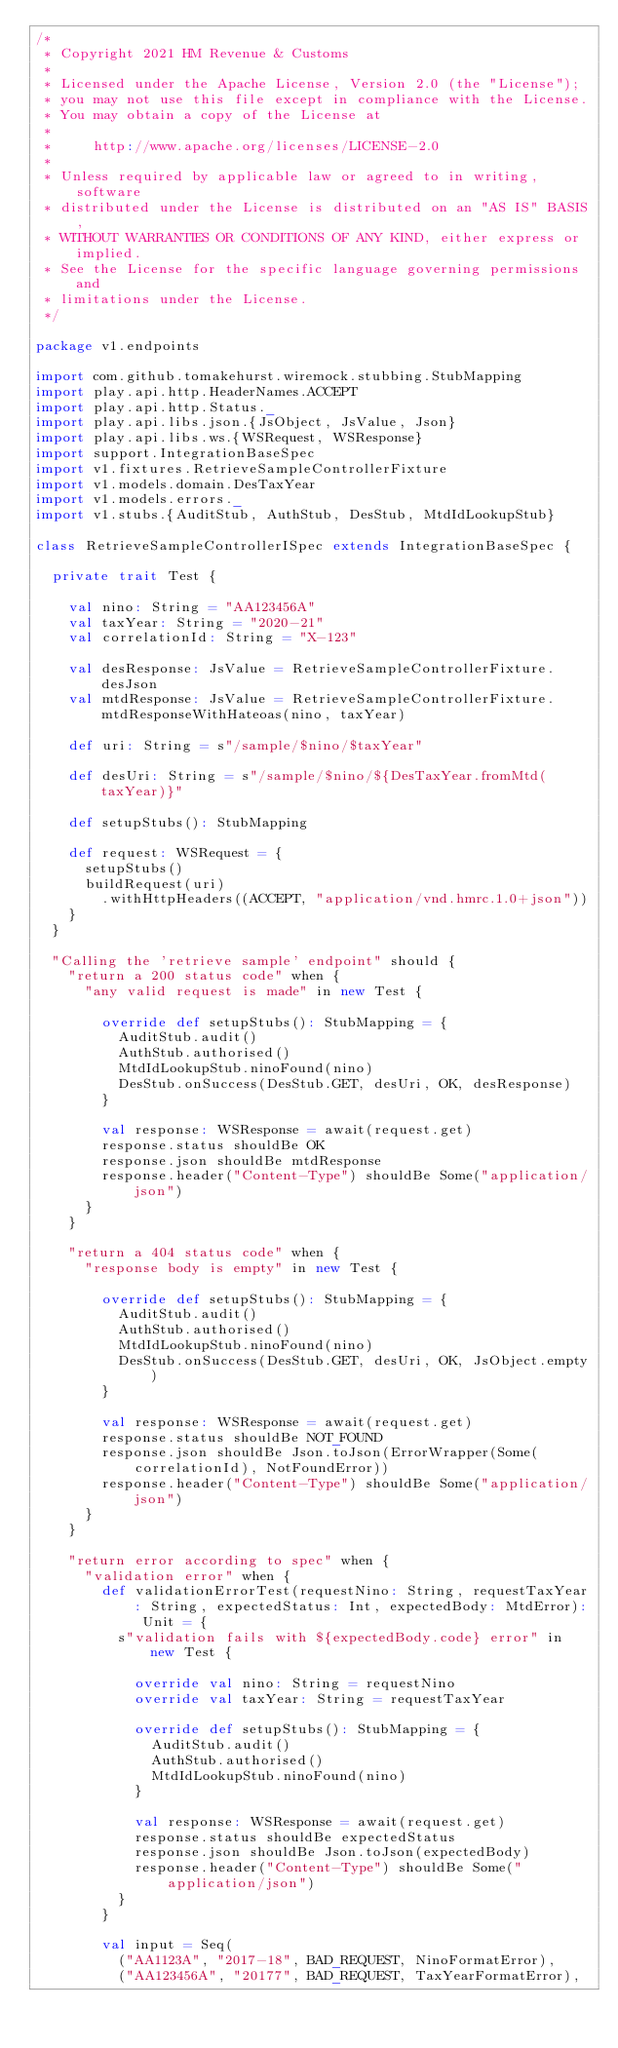<code> <loc_0><loc_0><loc_500><loc_500><_Scala_>/*
 * Copyright 2021 HM Revenue & Customs
 *
 * Licensed under the Apache License, Version 2.0 (the "License");
 * you may not use this file except in compliance with the License.
 * You may obtain a copy of the License at
 *
 *     http://www.apache.org/licenses/LICENSE-2.0
 *
 * Unless required by applicable law or agreed to in writing, software
 * distributed under the License is distributed on an "AS IS" BASIS,
 * WITHOUT WARRANTIES OR CONDITIONS OF ANY KIND, either express or implied.
 * See the License for the specific language governing permissions and
 * limitations under the License.
 */

package v1.endpoints

import com.github.tomakehurst.wiremock.stubbing.StubMapping
import play.api.http.HeaderNames.ACCEPT
import play.api.http.Status._
import play.api.libs.json.{JsObject, JsValue, Json}
import play.api.libs.ws.{WSRequest, WSResponse}
import support.IntegrationBaseSpec
import v1.fixtures.RetrieveSampleControllerFixture
import v1.models.domain.DesTaxYear
import v1.models.errors._
import v1.stubs.{AuditStub, AuthStub, DesStub, MtdIdLookupStub}

class RetrieveSampleControllerISpec extends IntegrationBaseSpec {

  private trait Test {

    val nino: String = "AA123456A"
    val taxYear: String = "2020-21"
    val correlationId: String = "X-123"

    val desResponse: JsValue = RetrieveSampleControllerFixture.desJson
    val mtdResponse: JsValue = RetrieveSampleControllerFixture.mtdResponseWithHateoas(nino, taxYear)

    def uri: String = s"/sample/$nino/$taxYear"

    def desUri: String = s"/sample/$nino/${DesTaxYear.fromMtd(taxYear)}"

    def setupStubs(): StubMapping

    def request: WSRequest = {
      setupStubs()
      buildRequest(uri)
        .withHttpHeaders((ACCEPT, "application/vnd.hmrc.1.0+json"))
    }
  }

  "Calling the 'retrieve sample' endpoint" should {
    "return a 200 status code" when {
      "any valid request is made" in new Test {

        override def setupStubs(): StubMapping = {
          AuditStub.audit()
          AuthStub.authorised()
          MtdIdLookupStub.ninoFound(nino)
          DesStub.onSuccess(DesStub.GET, desUri, OK, desResponse)
        }

        val response: WSResponse = await(request.get)
        response.status shouldBe OK
        response.json shouldBe mtdResponse
        response.header("Content-Type") shouldBe Some("application/json")
      }
    }

    "return a 404 status code" when {
      "response body is empty" in new Test {

        override def setupStubs(): StubMapping = {
          AuditStub.audit()
          AuthStub.authorised()
          MtdIdLookupStub.ninoFound(nino)
          DesStub.onSuccess(DesStub.GET, desUri, OK, JsObject.empty)
        }

        val response: WSResponse = await(request.get)
        response.status shouldBe NOT_FOUND
        response.json shouldBe Json.toJson(ErrorWrapper(Some(correlationId), NotFoundError))
        response.header("Content-Type") shouldBe Some("application/json")
      }
    }

    "return error according to spec" when {
      "validation error" when {
        def validationErrorTest(requestNino: String, requestTaxYear: String, expectedStatus: Int, expectedBody: MtdError): Unit = {
          s"validation fails with ${expectedBody.code} error" in new Test {

            override val nino: String = requestNino
            override val taxYear: String = requestTaxYear

            override def setupStubs(): StubMapping = {
              AuditStub.audit()
              AuthStub.authorised()
              MtdIdLookupStub.ninoFound(nino)
            }

            val response: WSResponse = await(request.get)
            response.status shouldBe expectedStatus
            response.json shouldBe Json.toJson(expectedBody)
            response.header("Content-Type") shouldBe Some("application/json")
          }
        }

        val input = Seq(
          ("AA1123A", "2017-18", BAD_REQUEST, NinoFormatError),
          ("AA123456A", "20177", BAD_REQUEST, TaxYearFormatError),</code> 